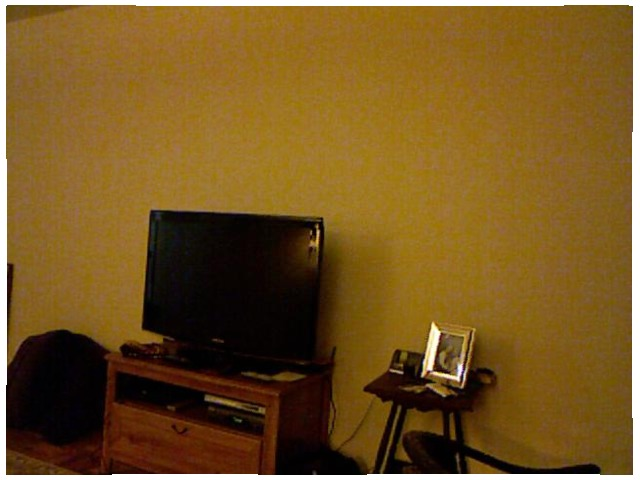<image>
Can you confirm if the monitor is on the table? Yes. Looking at the image, I can see the monitor is positioned on top of the table, with the table providing support. Where is the wall in relation to the tv? Is it behind the tv? Yes. From this viewpoint, the wall is positioned behind the tv, with the tv partially or fully occluding the wall. 